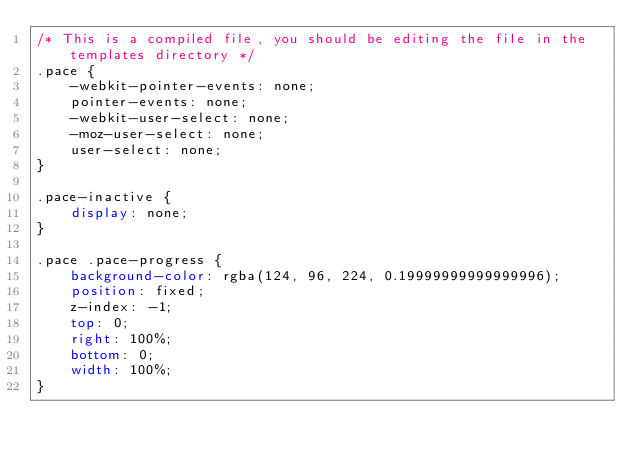Convert code to text. <code><loc_0><loc_0><loc_500><loc_500><_CSS_>/* This is a compiled file, you should be editing the file in the templates directory */
.pace {
    -webkit-pointer-events: none;
    pointer-events: none;
    -webkit-user-select: none;
    -moz-user-select: none;
    user-select: none;
}

.pace-inactive {
    display: none;
}

.pace .pace-progress {
    background-color: rgba(124, 96, 224, 0.19999999999999996);
    position: fixed;
    z-index: -1;
    top: 0;
    right: 100%;
    bottom: 0;
    width: 100%;
}
</code> 